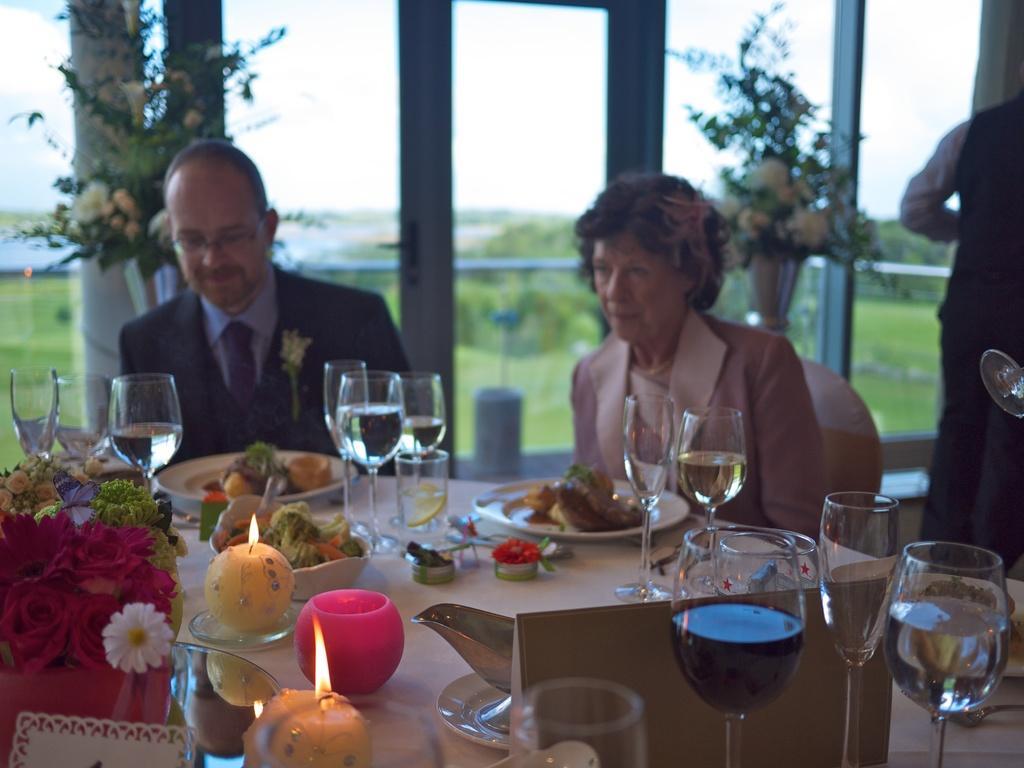Can you describe this image briefly? On the right corner of the picture, woman in brown blazer is sitting on chair. Beside her, we see man in black blazer and blue shirt is sitting on chair and he is smiling. In front of them, we see a table on which plate containing food, glass with water, bowl containing fruits, candle, flower pot and a jar are placed on the table. Behind these people, we see plants and beside them, we see window from which we see trees and sky. On the right corner of the picture, we see man standing. 